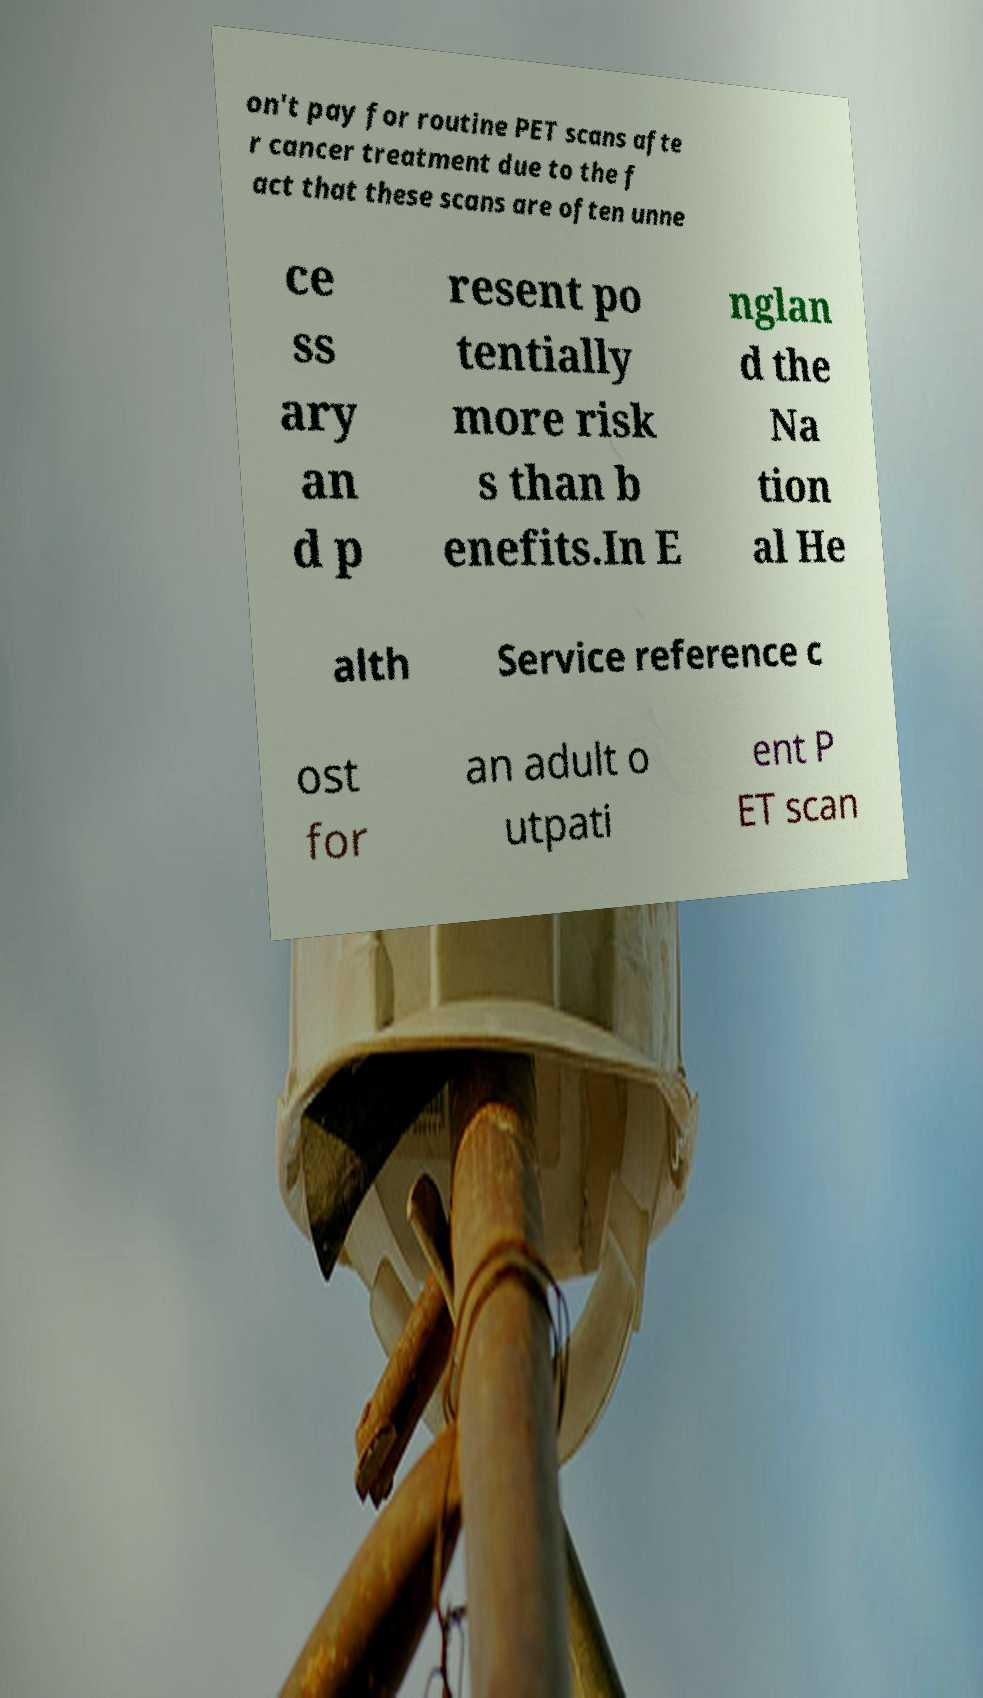Can you read and provide the text displayed in the image?This photo seems to have some interesting text. Can you extract and type it out for me? on't pay for routine PET scans afte r cancer treatment due to the f act that these scans are often unne ce ss ary an d p resent po tentially more risk s than b enefits.In E nglan d the Na tion al He alth Service reference c ost for an adult o utpati ent P ET scan 